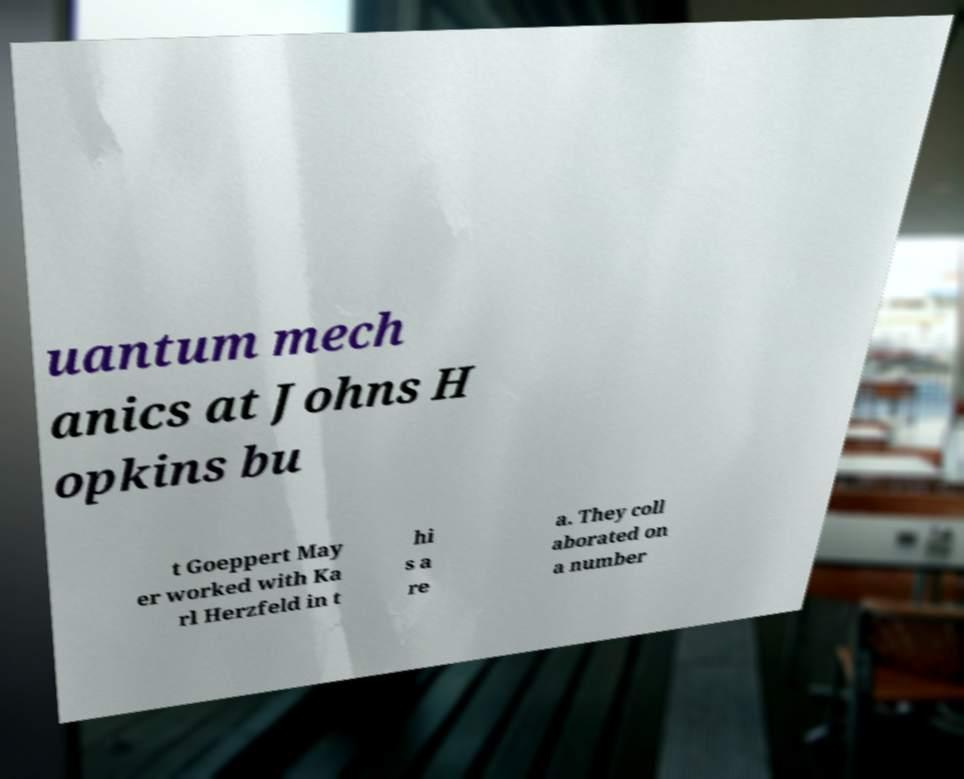What messages or text are displayed in this image? I need them in a readable, typed format. uantum mech anics at Johns H opkins bu t Goeppert May er worked with Ka rl Herzfeld in t hi s a re a. They coll aborated on a number 